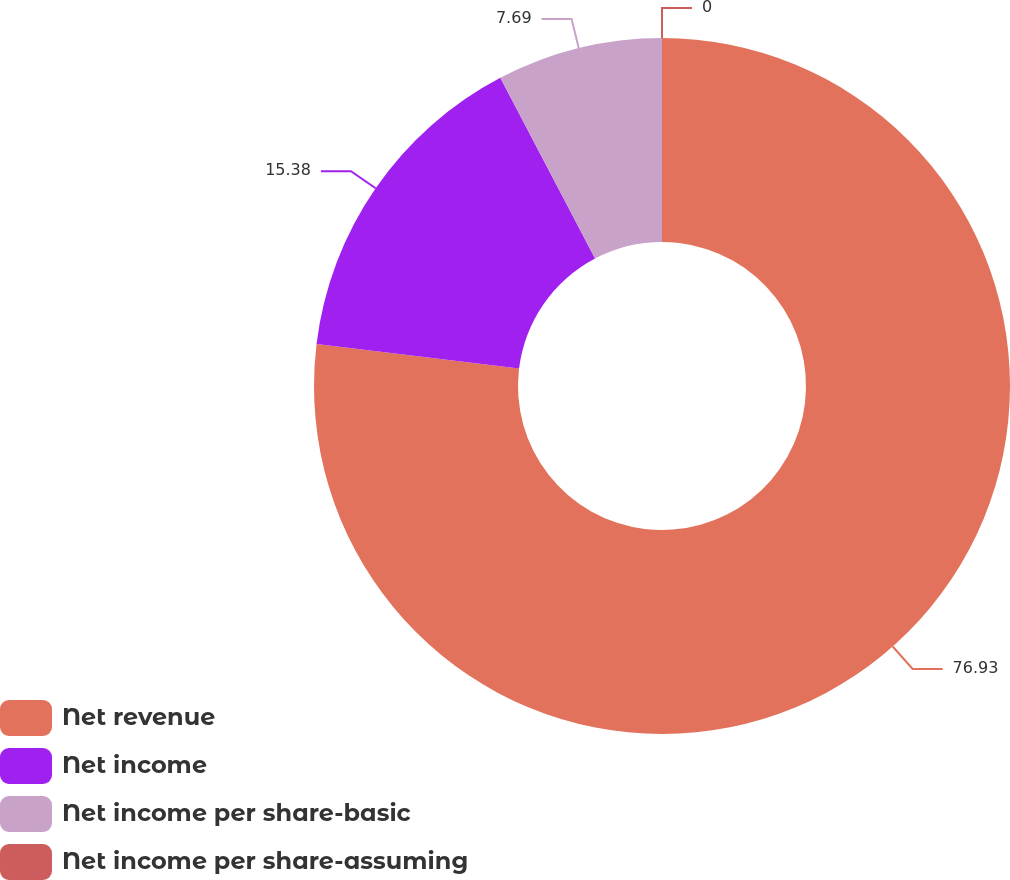<chart> <loc_0><loc_0><loc_500><loc_500><pie_chart><fcel>Net revenue<fcel>Net income<fcel>Net income per share-basic<fcel>Net income per share-assuming<nl><fcel>76.92%<fcel>15.38%<fcel>7.69%<fcel>0.0%<nl></chart> 